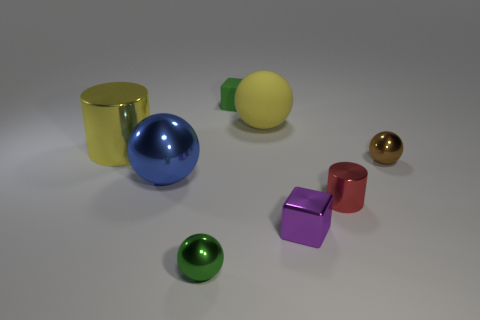Subtract 1 spheres. How many spheres are left? 3 Add 2 large yellow metal cylinders. How many objects exist? 10 Subtract all blocks. How many objects are left? 6 Subtract all large matte cylinders. Subtract all tiny brown objects. How many objects are left? 7 Add 5 blue spheres. How many blue spheres are left? 6 Add 5 tiny purple cubes. How many tiny purple cubes exist? 6 Subtract 0 cyan cylinders. How many objects are left? 8 